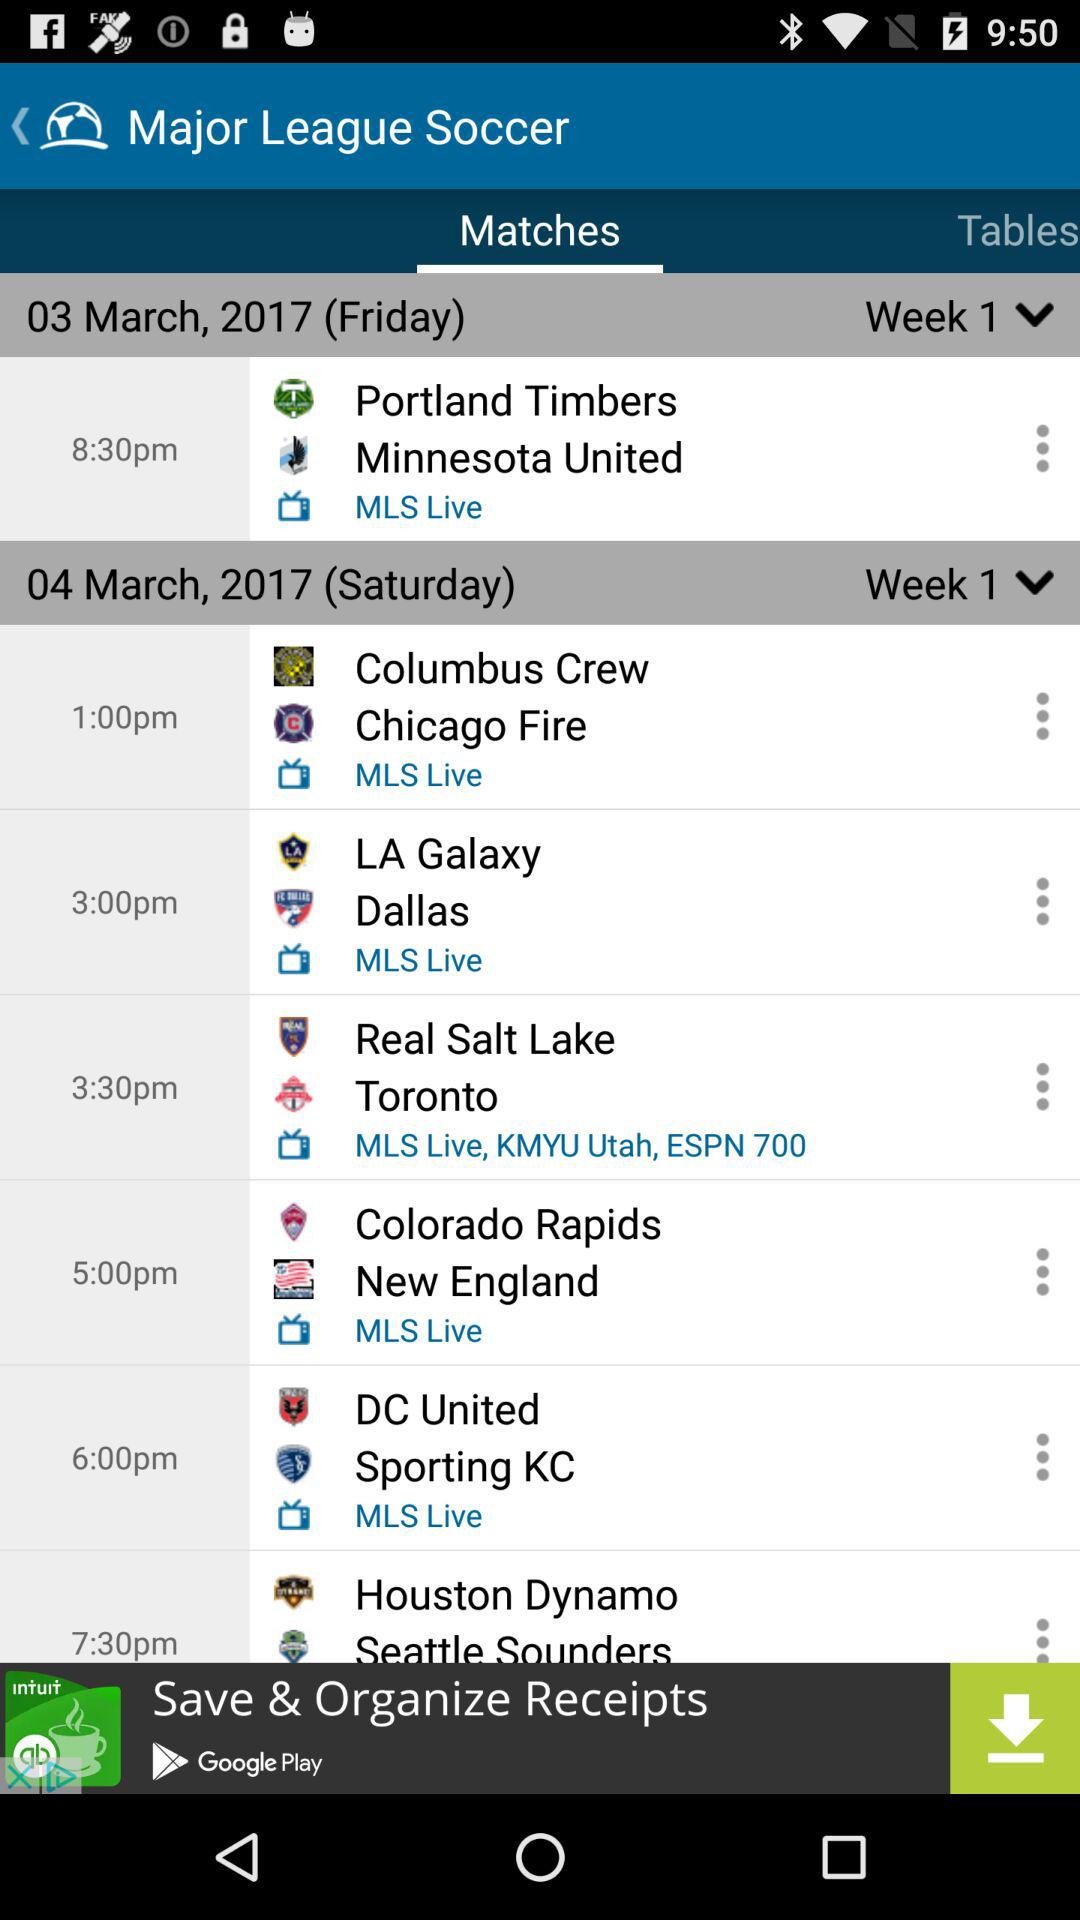What are the teams that are having a match on March 3rd? The teams are "Portland Timbers" and "Minnesota United". 